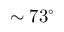<formula> <loc_0><loc_0><loc_500><loc_500>\sim 7 3 ^ { \circ }</formula> 